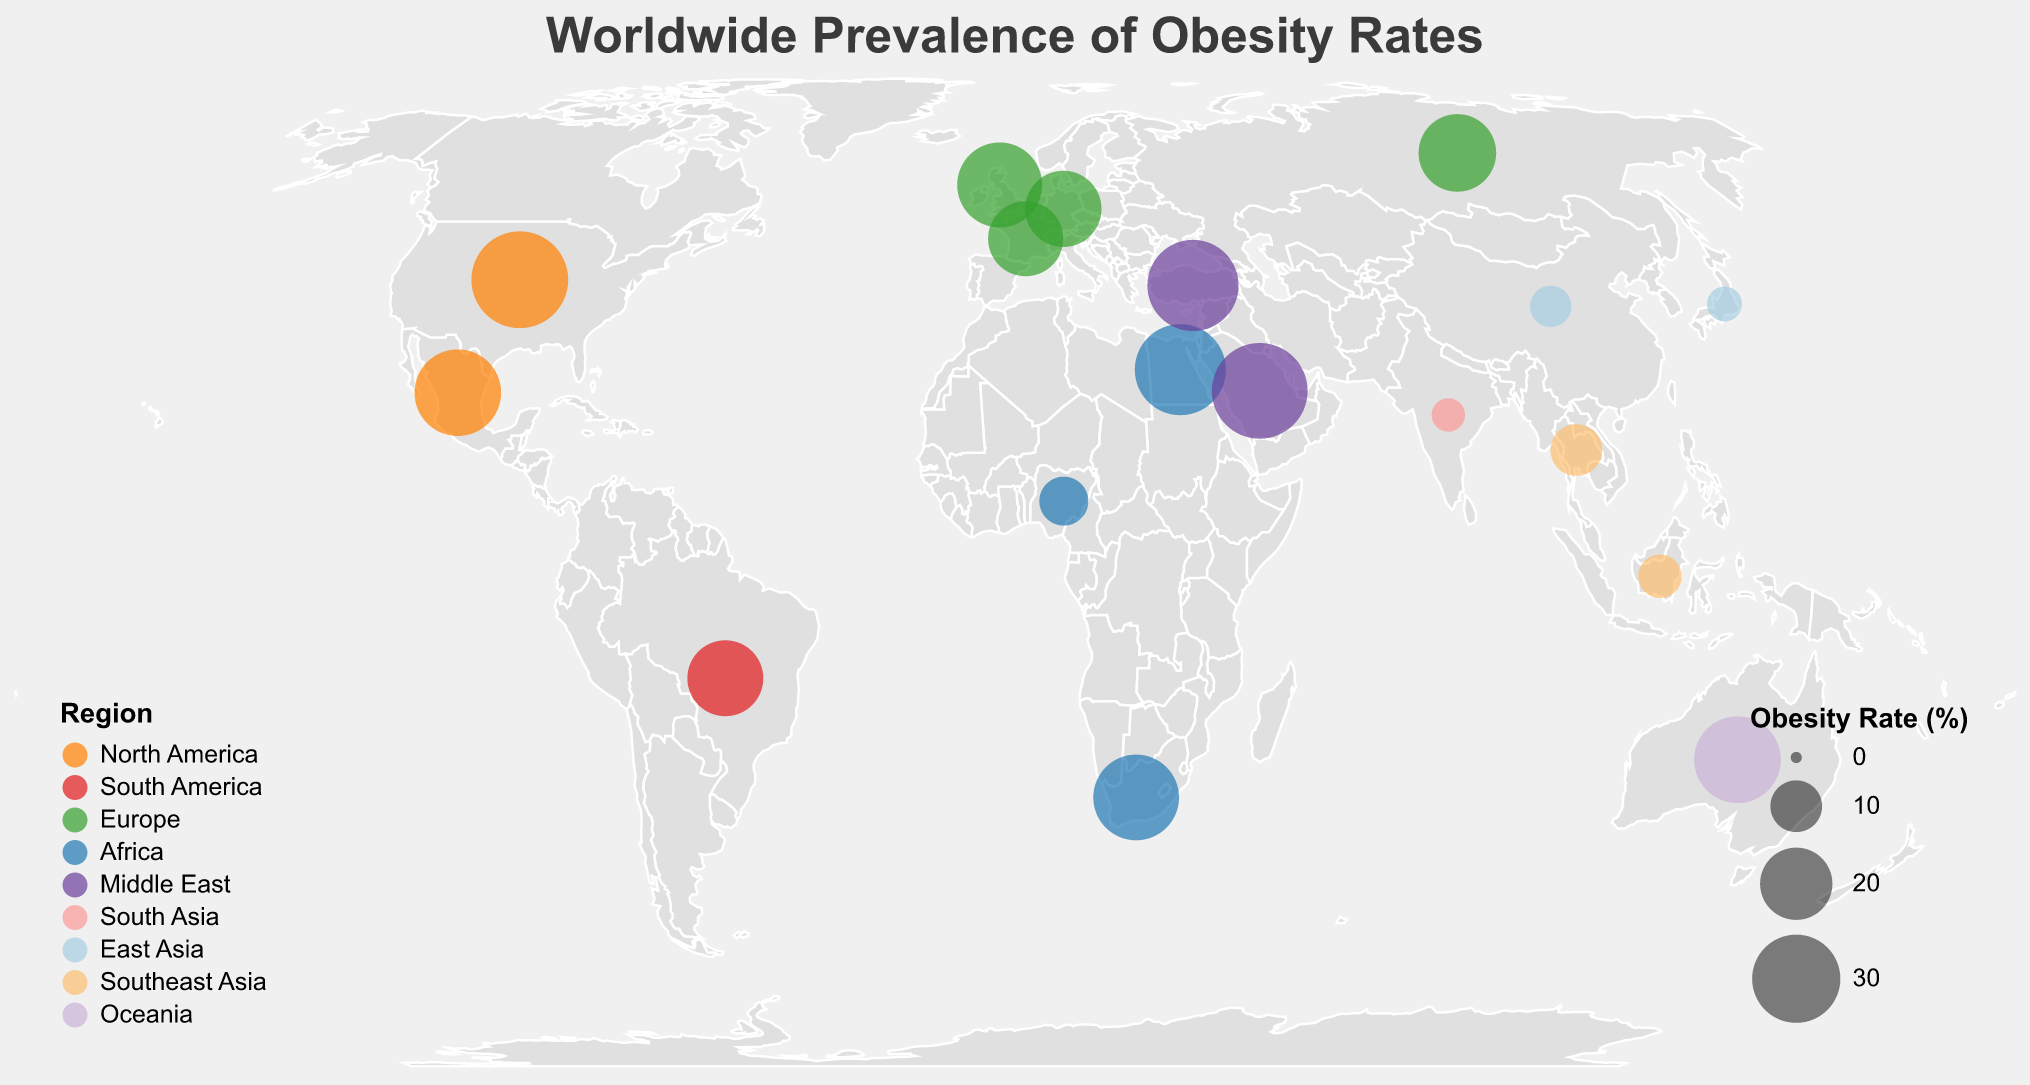Which country has the highest obesity rate? By looking at the size of the circles on the map, the largest circle indicates the highest obesity rate, which is in the United States.
Answer: United States Which region has the most countries with high obesity rates (greater than 30%)? By observing the colors of the circles corresponding to obesity rates higher than 30%, the Middle East and Africa regions have multiple countries (Egypt, Saudi Arabia, Turkey) with obesity rates above 30%.
Answer: Middle East How does the obesity rate in Australia compare to that in Indonesia? The size of the circle for Australia (29.0%) is significantly larger than that for Indonesia (6.9%), indicating that Australia's obesity rate is much higher than Indonesia's.
Answer: Greater in Australia Which region has the lowest overall obesity rates based on the data points provided? By comparing the circle sizes and colors, South Asia (with countries like India having an obesity rate of only 3.9%) has the lowest obesity rates overall.
Answer: South Asia What's the difference in obesity rates between the country with the highest rate and the one with the lowest rate? The highest rate is the United States at 36.2%, and the lowest is India at 3.9%. The difference is calculated as 36.2 - 3.9 = 32.3.
Answer: 32.3% Which countries in Europe have obesity rates above 25%? Identifying the circle sizes in Europe, the United Kingdom with 27.8% is the country with an obesity rate above 25%.
Answer: United Kingdom What is the average obesity rate of the countries in North America? North America includes the United States (36.2%) and Mexico (28.9%). The average rate is calculated as (36.2 + 28.9) / 2 = 32.55.
Answer: 32.55% Which two regions have similar obesity rates and what are those rates? Comparing the circle sizes and colors, Oceania (Australia, 29.0%) and North America (Mexico, 28.9%) have similar obesity rates.
Answer: Oceania and North America How does the obesity rate in Europe compare to that in Africa? By identifying the circle sizes for both regions, Europe's countries show varying rates (21.6% to 27.8%), while Africa's rates range from 8.9% to 32%. On average, Africa shows a greater variation but includes a higher maximum rate in Egypt.
Answer: Africa has a broader range and higher maximum rate in Egypt What is the obesity rate range in Southeast Asia? Observing the circle sizes in Southeast Asia, Indonesia has a rate of 6.9% and Thailand has a rate of 10.0%, creating a range from 6.9% to 10.0%.
Answer: 6.9% to 10.0% 